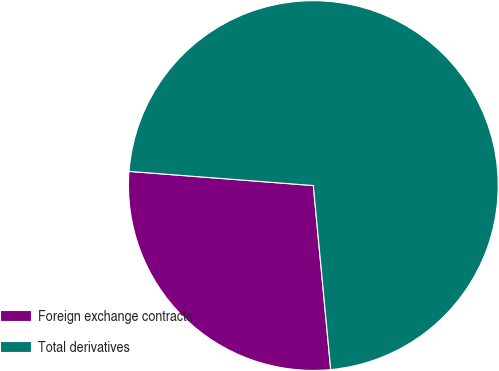<chart> <loc_0><loc_0><loc_500><loc_500><pie_chart><fcel>Foreign exchange contracts<fcel>Total derivatives<nl><fcel>27.72%<fcel>72.28%<nl></chart> 